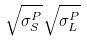<formula> <loc_0><loc_0><loc_500><loc_500>\sqrt { \sigma _ { S } ^ { P } } \sqrt { \sigma _ { L } ^ { P } }</formula> 